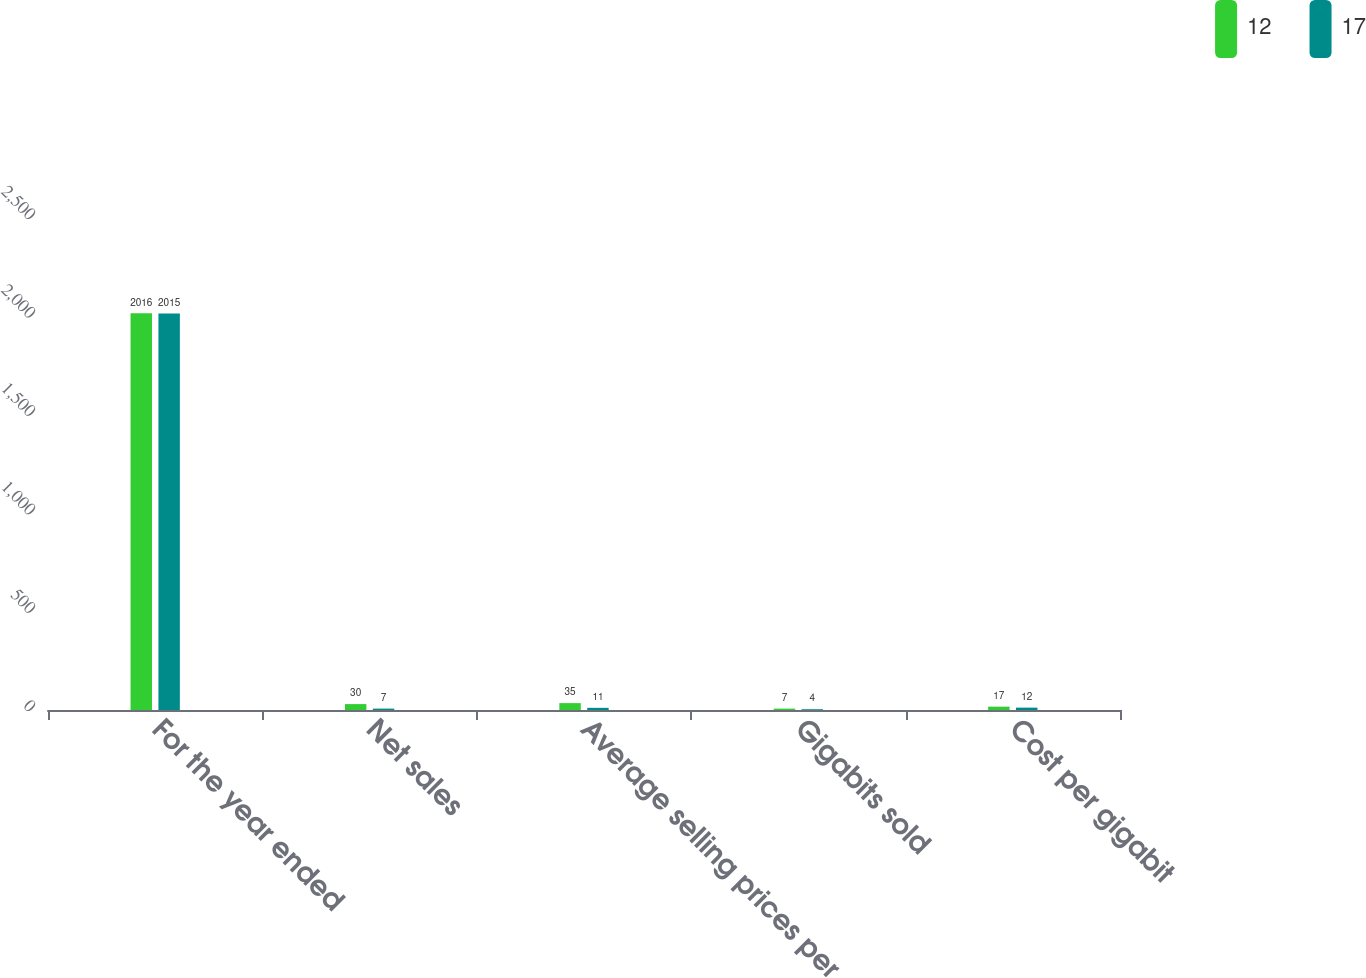<chart> <loc_0><loc_0><loc_500><loc_500><stacked_bar_chart><ecel><fcel>For the year ended<fcel>Net sales<fcel>Average selling prices per<fcel>Gigabits sold<fcel>Cost per gigabit<nl><fcel>12<fcel>2016<fcel>30<fcel>35<fcel>7<fcel>17<nl><fcel>17<fcel>2015<fcel>7<fcel>11<fcel>4<fcel>12<nl></chart> 